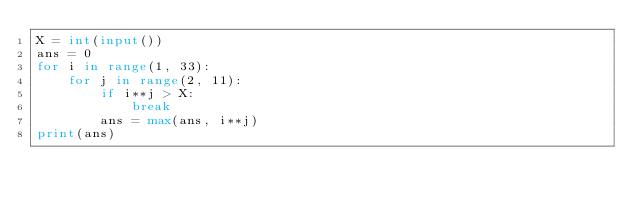<code> <loc_0><loc_0><loc_500><loc_500><_Python_>X = int(input())
ans = 0
for i in range(1, 33):
    for j in range(2, 11):
        if i**j > X:
            break
        ans = max(ans, i**j)
print(ans)</code> 